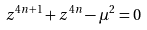Convert formula to latex. <formula><loc_0><loc_0><loc_500><loc_500>z ^ { 4 n + 1 } + z ^ { 4 n } - \mu ^ { 2 } = 0</formula> 